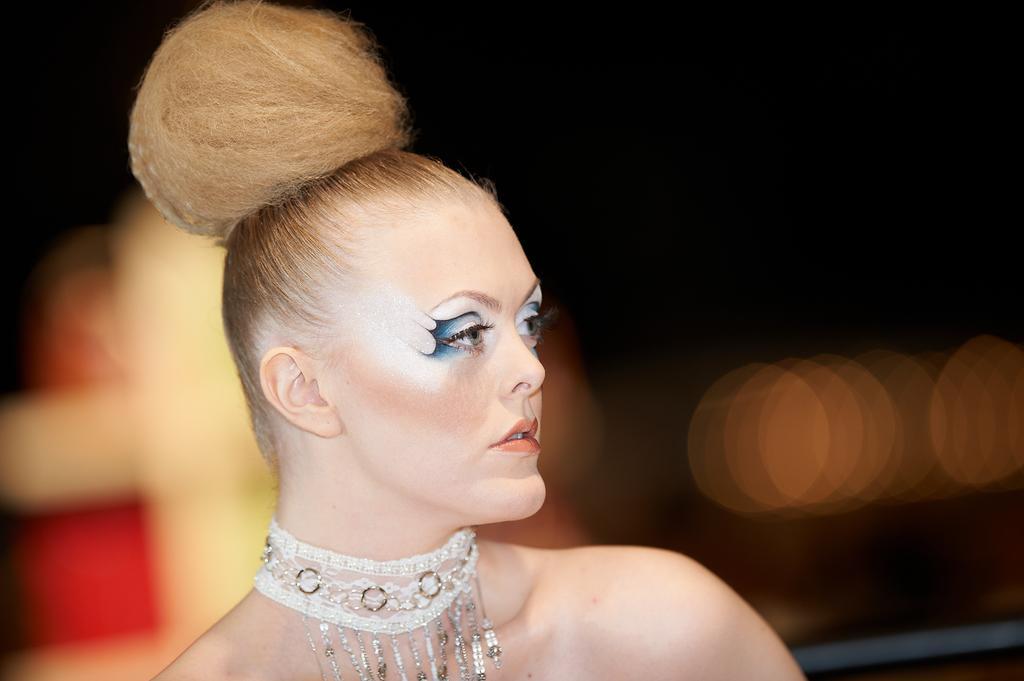Can you describe this image briefly? There is a woman wore ornament. In background it is dark and blur. 